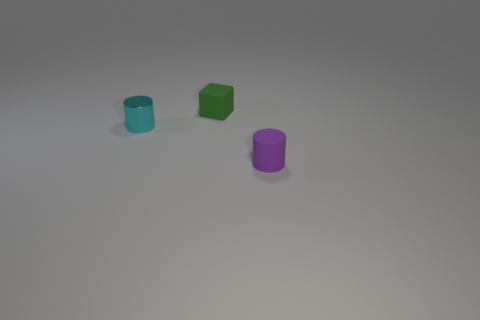Subtract all blue cylinders. Subtract all cyan blocks. How many cylinders are left? 2 Add 1 large blue rubber balls. How many objects exist? 4 Subtract all cylinders. How many objects are left? 1 Add 2 small purple cylinders. How many small purple cylinders are left? 3 Add 3 cyan metal objects. How many cyan metal objects exist? 4 Subtract 0 brown spheres. How many objects are left? 3 Subtract all yellow spheres. Subtract all small cyan metal things. How many objects are left? 2 